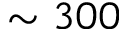<formula> <loc_0><loc_0><loc_500><loc_500>\sim 3 0 0</formula> 